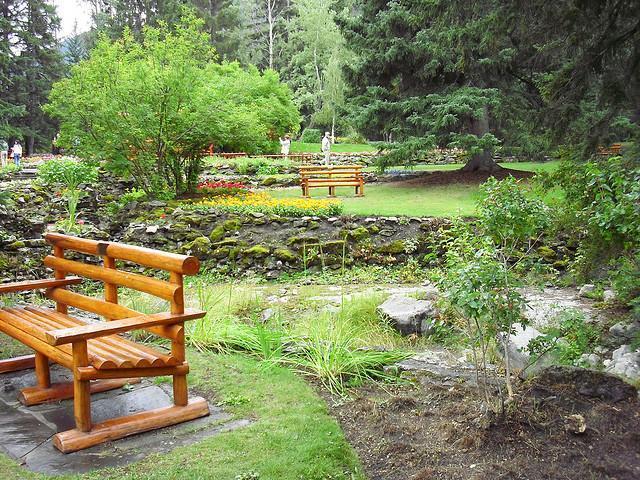How many benches are depicted?
Give a very brief answer. 2. 